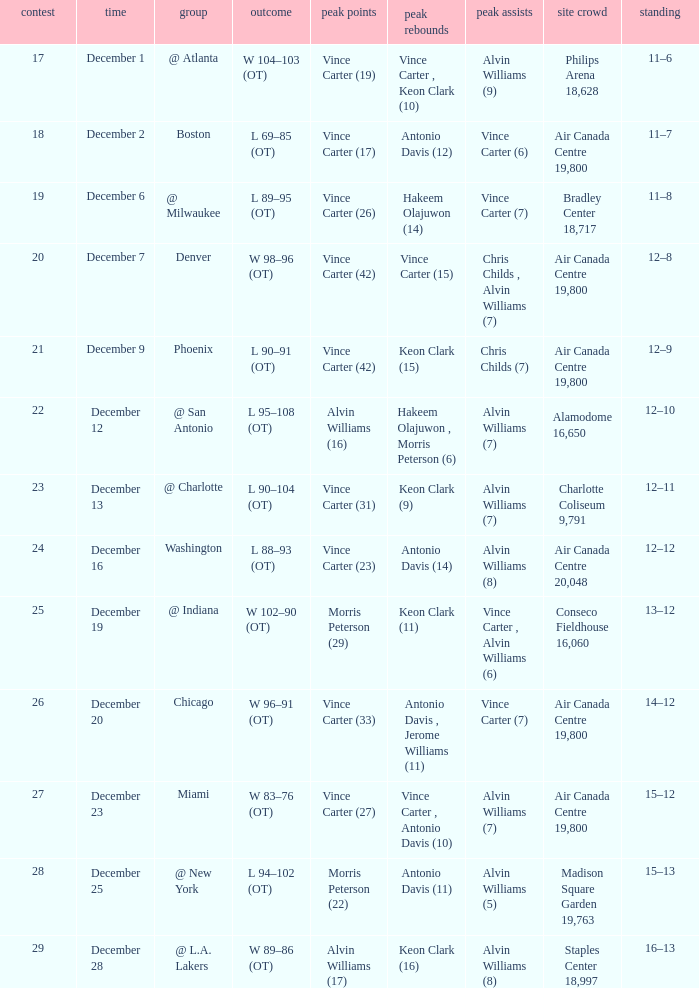Who scored the most points against Washington? Vince Carter (23). 